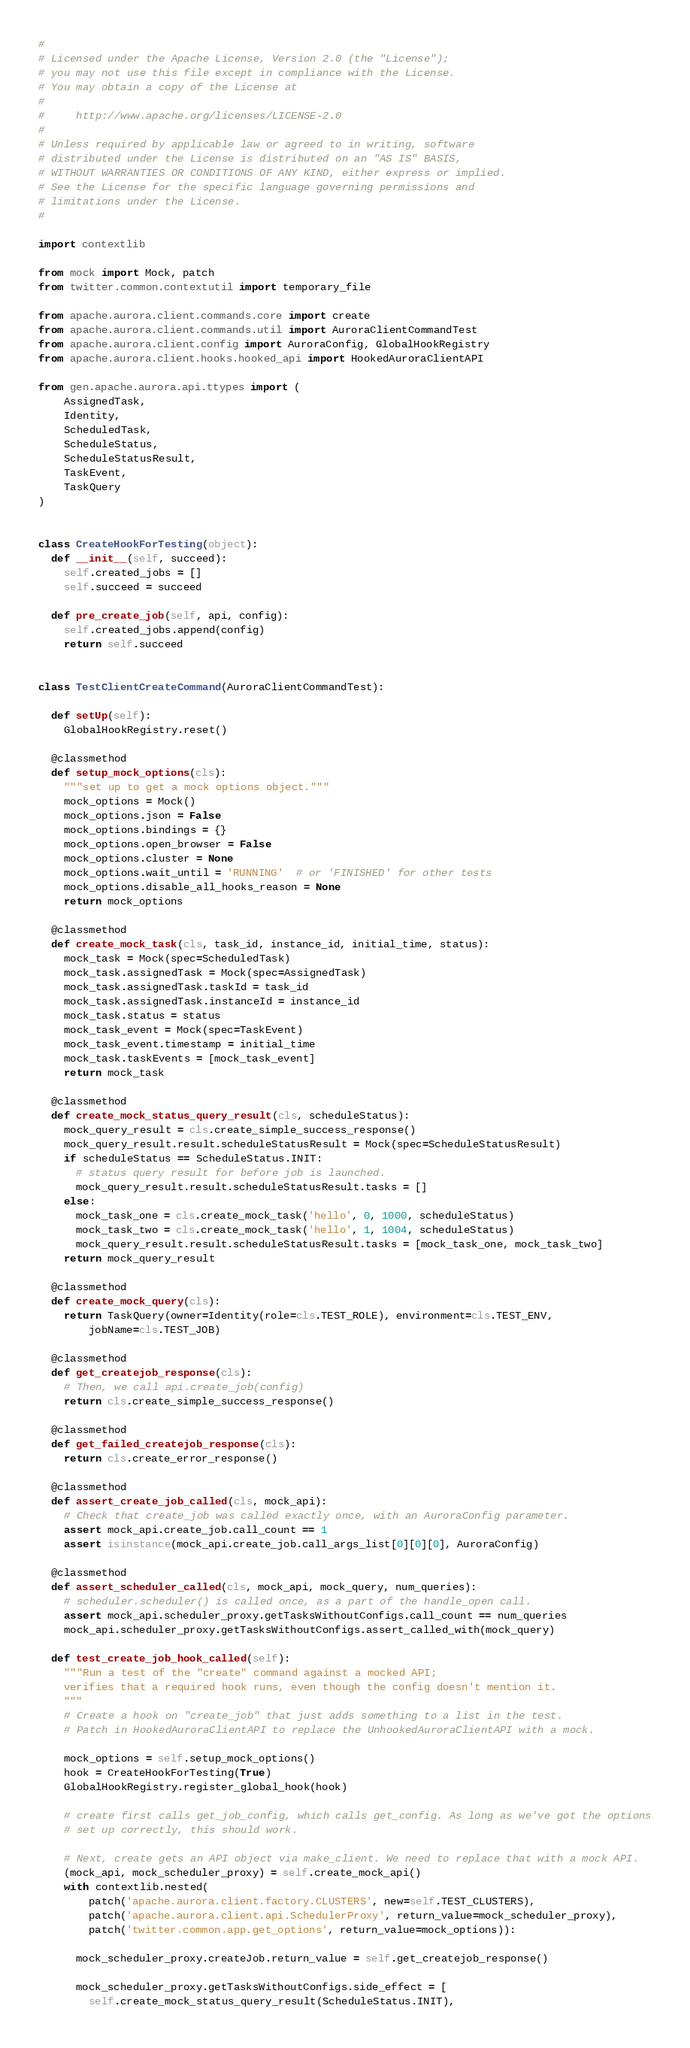Convert code to text. <code><loc_0><loc_0><loc_500><loc_500><_Python_>#
# Licensed under the Apache License, Version 2.0 (the "License");
# you may not use this file except in compliance with the License.
# You may obtain a copy of the License at
#
#     http://www.apache.org/licenses/LICENSE-2.0
#
# Unless required by applicable law or agreed to in writing, software
# distributed under the License is distributed on an "AS IS" BASIS,
# WITHOUT WARRANTIES OR CONDITIONS OF ANY KIND, either express or implied.
# See the License for the specific language governing permissions and
# limitations under the License.
#

import contextlib

from mock import Mock, patch
from twitter.common.contextutil import temporary_file

from apache.aurora.client.commands.core import create
from apache.aurora.client.commands.util import AuroraClientCommandTest
from apache.aurora.client.config import AuroraConfig, GlobalHookRegistry
from apache.aurora.client.hooks.hooked_api import HookedAuroraClientAPI

from gen.apache.aurora.api.ttypes import (
    AssignedTask,
    Identity,
    ScheduledTask,
    ScheduleStatus,
    ScheduleStatusResult,
    TaskEvent,
    TaskQuery
)


class CreateHookForTesting(object):
  def __init__(self, succeed):
    self.created_jobs = []
    self.succeed = succeed

  def pre_create_job(self, api, config):
    self.created_jobs.append(config)
    return self.succeed


class TestClientCreateCommand(AuroraClientCommandTest):

  def setUp(self):
    GlobalHookRegistry.reset()

  @classmethod
  def setup_mock_options(cls):
    """set up to get a mock options object."""
    mock_options = Mock()
    mock_options.json = False
    mock_options.bindings = {}
    mock_options.open_browser = False
    mock_options.cluster = None
    mock_options.wait_until = 'RUNNING'  # or 'FINISHED' for other tests
    mock_options.disable_all_hooks_reason = None
    return mock_options

  @classmethod
  def create_mock_task(cls, task_id, instance_id, initial_time, status):
    mock_task = Mock(spec=ScheduledTask)
    mock_task.assignedTask = Mock(spec=AssignedTask)
    mock_task.assignedTask.taskId = task_id
    mock_task.assignedTask.instanceId = instance_id
    mock_task.status = status
    mock_task_event = Mock(spec=TaskEvent)
    mock_task_event.timestamp = initial_time
    mock_task.taskEvents = [mock_task_event]
    return mock_task

  @classmethod
  def create_mock_status_query_result(cls, scheduleStatus):
    mock_query_result = cls.create_simple_success_response()
    mock_query_result.result.scheduleStatusResult = Mock(spec=ScheduleStatusResult)
    if scheduleStatus == ScheduleStatus.INIT:
      # status query result for before job is launched.
      mock_query_result.result.scheduleStatusResult.tasks = []
    else:
      mock_task_one = cls.create_mock_task('hello', 0, 1000, scheduleStatus)
      mock_task_two = cls.create_mock_task('hello', 1, 1004, scheduleStatus)
      mock_query_result.result.scheduleStatusResult.tasks = [mock_task_one, mock_task_two]
    return mock_query_result

  @classmethod
  def create_mock_query(cls):
    return TaskQuery(owner=Identity(role=cls.TEST_ROLE), environment=cls.TEST_ENV,
        jobName=cls.TEST_JOB)

  @classmethod
  def get_createjob_response(cls):
    # Then, we call api.create_job(config)
    return cls.create_simple_success_response()

  @classmethod
  def get_failed_createjob_response(cls):
    return cls.create_error_response()

  @classmethod
  def assert_create_job_called(cls, mock_api):
    # Check that create_job was called exactly once, with an AuroraConfig parameter.
    assert mock_api.create_job.call_count == 1
    assert isinstance(mock_api.create_job.call_args_list[0][0][0], AuroraConfig)

  @classmethod
  def assert_scheduler_called(cls, mock_api, mock_query, num_queries):
    # scheduler.scheduler() is called once, as a part of the handle_open call.
    assert mock_api.scheduler_proxy.getTasksWithoutConfigs.call_count == num_queries
    mock_api.scheduler_proxy.getTasksWithoutConfigs.assert_called_with(mock_query)

  def test_create_job_hook_called(self):
    """Run a test of the "create" command against a mocked API;
    verifies that a required hook runs, even though the config doesn't mention it.
    """
    # Create a hook on "create_job" that just adds something to a list in the test.
    # Patch in HookedAuroraClientAPI to replace the UnhookedAuroraClientAPI with a mock.

    mock_options = self.setup_mock_options()
    hook = CreateHookForTesting(True)
    GlobalHookRegistry.register_global_hook(hook)

    # create first calls get_job_config, which calls get_config. As long as we've got the options
    # set up correctly, this should work.

    # Next, create gets an API object via make_client. We need to replace that with a mock API.
    (mock_api, mock_scheduler_proxy) = self.create_mock_api()
    with contextlib.nested(
        patch('apache.aurora.client.factory.CLUSTERS', new=self.TEST_CLUSTERS),
        patch('apache.aurora.client.api.SchedulerProxy', return_value=mock_scheduler_proxy),
        patch('twitter.common.app.get_options', return_value=mock_options)):

      mock_scheduler_proxy.createJob.return_value = self.get_createjob_response()

      mock_scheduler_proxy.getTasksWithoutConfigs.side_effect = [
        self.create_mock_status_query_result(ScheduleStatus.INIT),</code> 